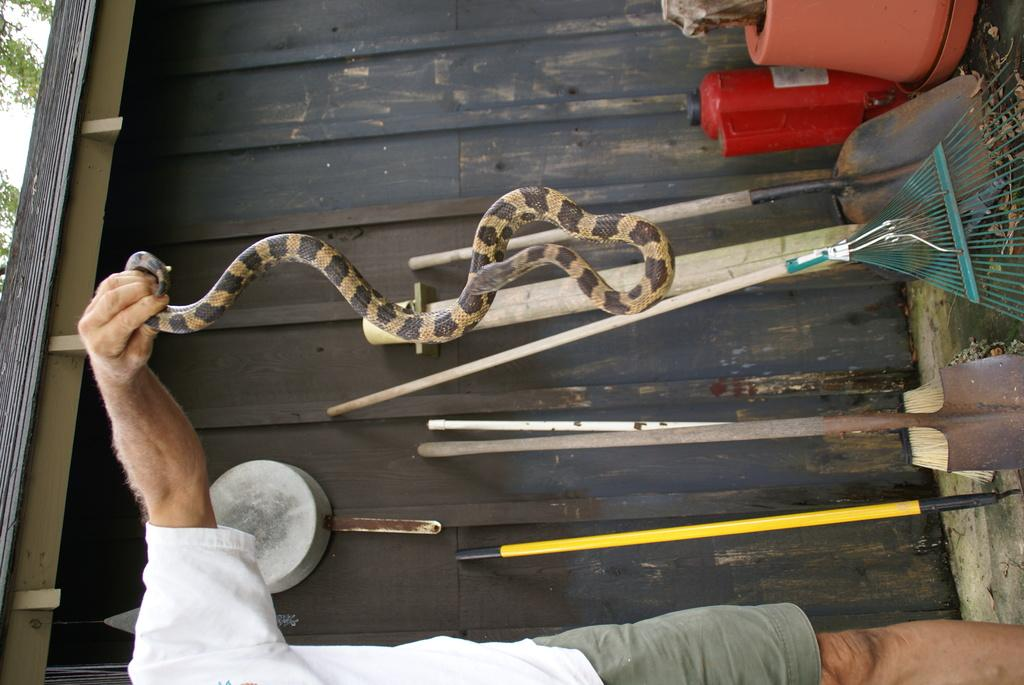What is the main subject of the image? There is a man in the image. What is the man doing in the image? The man is standing and holding a snake in his hand. What objects can be seen in the image related to cleaning or gardening? There are brooms and digging tools in the image. What structures are visible in the image? There is a house and a tree in the image. Where is the nest located in the image? There is no nest present in the image. What type of sweater is the man wearing in the image? The man is not wearing a sweater in the image; he is holding a snake in his hand. 